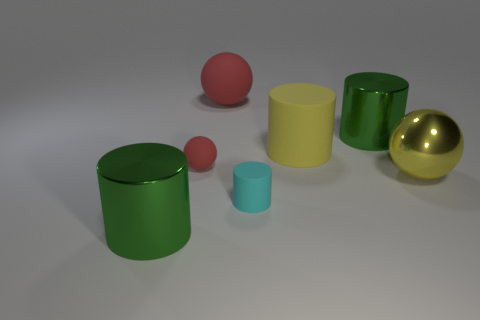Imagine these objects are part of an art exhibit. What artistic concepts could they represent? As part of an art exhibit, these objects might represent minimalist aesthetics, focusing on fundamental geometric shapes and primary colors. They could symbolize harmony and balance through their spatial distribution, and the contrast of textures—shiny versus matte—might suggest a discourse on visual perception and materiality. 